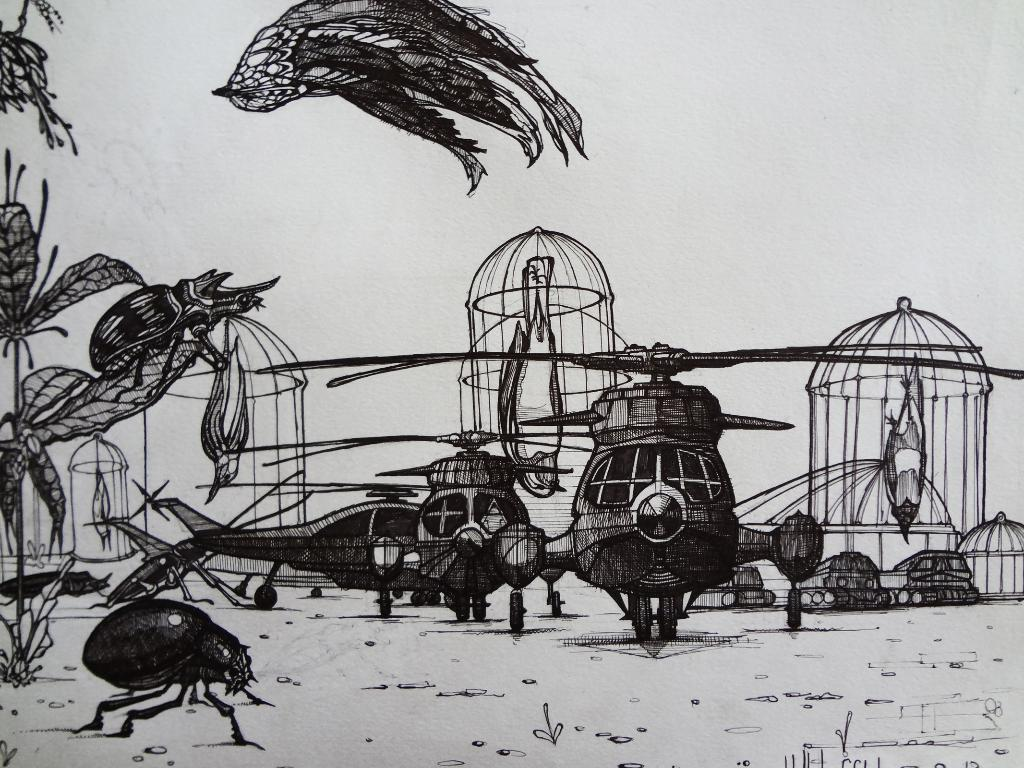What type of enclosures are present in the image? There are cages in the image. What animals can be seen inside the cages? There are birds in the image. What other objects or vehicles are present in the image? There are helicopters in the image. What type of chain can be seen connecting the sidewalk to the journey in the image? There is no chain, sidewalk, or journey present in the image. 